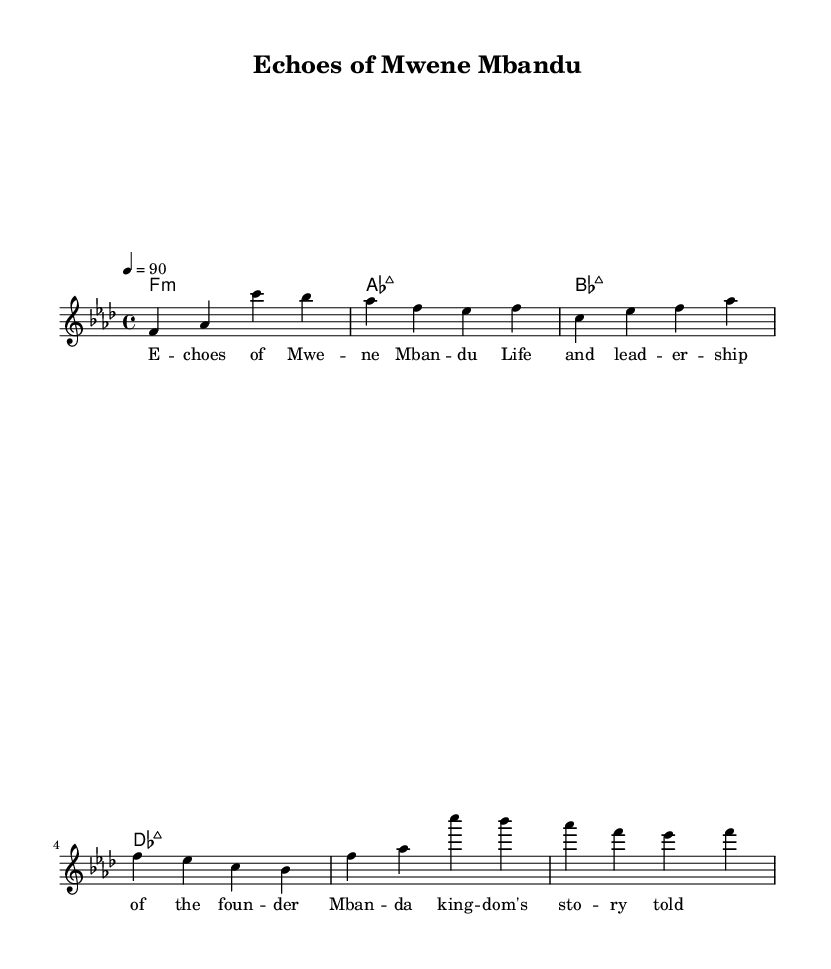what is the key signature of this music? The key signature is F minor, which is indicated by the presence of four flats (B, E, A, D) in the key signature. This can be deduced from the "global" sections where the key is declared.
Answer: F minor what is the time signature of this music? The time signature is 4/4, indicated in the global section where it is stated as "\time 4/4". This means there are four beats in each measure.
Answer: 4/4 what is the tempo marking of this music? The tempo marking is 90 beats per minute, indicated by the notation "4 = 90" in the global section. This defines the pace at which the piece should be played.
Answer: 90 how many measures does the verse section contain? The verse section consists of 8 notes in the melody part, which equates to 2 measures in a 4/4 time signature (4 beats per measure). This is seen in the distribution of notes through the verse.
Answer: 2 what is the overall theme of the lyrics? The overall theme of the lyrics is the history and leadership of the Mbunda people, as indicated by phrases such as "Life and leadership of the founder" and "Mbandu kingdom's story told." This reflects the storytelling nature of Hip Hop in relation to history.
Answer: history and leadership what genre does this piece represent? The genre represented by this piece is Hip Hop, which is characterized by storytelling and rhythmic vocal delivery, as seen in the lyrical content focusing on significant historical events.
Answer: Hip Hop what is the first note of the chorus? The first note of the chorus is F, as indicated in the melody section where the note sequence starts with "f'" at the beginning of the chorus.
Answer: F 